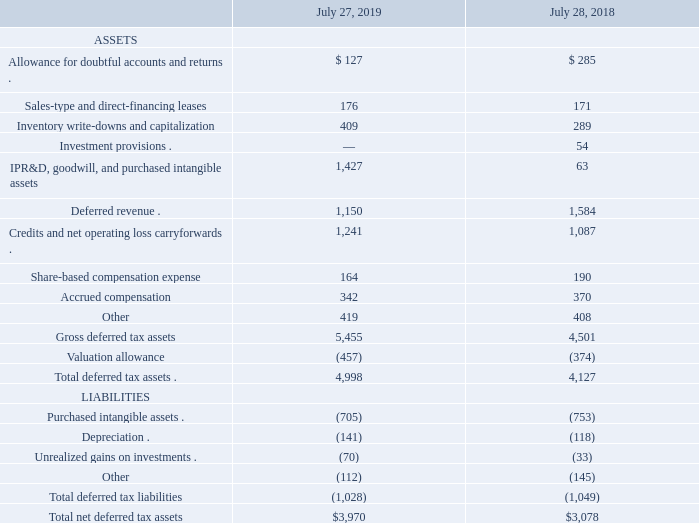The following table presents the components of the deferred tax assets and liabilities (in millions):
As of July 27, 2019, our federal, state, and foreign net operating loss carryforwards for income tax purposes were $676 million, $1 billion, and $756 million, respectively. A significant amount of the net operating loss carryforwards relates to acquisitions and, as a result, is limited in the amount that can be recognized in any one year. If not utilized, the federal, state and foreign net operating loss carryforwards will begin to expire in fiscal 2020. We have provided a valuation allowance of $111 million for deferred tax assets related to foreign net operating losses that are not expected to be realized.
As of July 27, 2019, our federal, state, and foreign tax credit carryforwards for income tax purposes were approximately $25 million, $1.1 billion, and $5 million, respectively. The federal tax credit carryforwards will begin to expire in fiscal 2020. The majority of state and foreign tax credits can be carried forward indefinitely. We have provided a valuation allowance of $346 million for deferred tax assets related to state and foreign tax credits that are not expected to be realized.
What was the company's federal net operating loss carryforwards for income tax purposes in 2019? $676 million. What was the Sales-type and direct-financing leases in 2019?
Answer scale should be: million. 176. What was the depreciation in 2018?
Answer scale should be: million. (118). What was the change in Share-based compensation expense between 2018 and 2019?
Answer scale should be: million. 164-190
Answer: -26. What was the change in Accrued compensation between 2018 and 2019?
Answer scale should be: million. 342-370
Answer: -28. What was the percentage change in total deferred tax assets between 2018 and 2019?
Answer scale should be: percent. (4,998-4,127)/4,127
Answer: 21.1. 